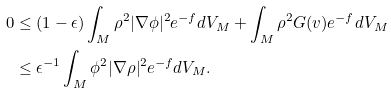Convert formula to latex. <formula><loc_0><loc_0><loc_500><loc_500>0 & \leq ( 1 - \epsilon ) \int _ { M } \rho ^ { 2 } | \nabla \phi | ^ { 2 } e ^ { - f } d V _ { M } + \int _ { M } \rho ^ { 2 } G ( v ) e ^ { - f } d V _ { M } \\ & \leq \epsilon ^ { - 1 } \int _ { M } \phi ^ { 2 } | \nabla \rho | ^ { 2 } e ^ { - f } d V _ { M } .</formula> 